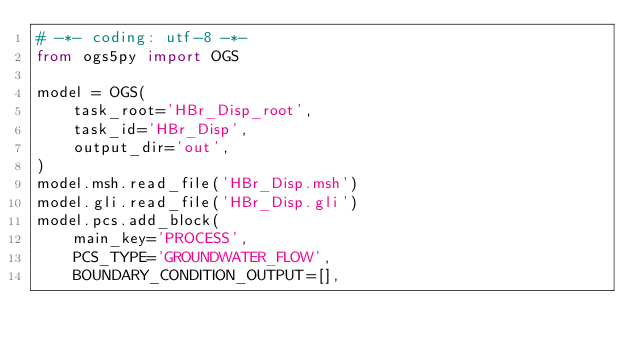<code> <loc_0><loc_0><loc_500><loc_500><_Python_># -*- coding: utf-8 -*-
from ogs5py import OGS

model = OGS(
    task_root='HBr_Disp_root',
    task_id='HBr_Disp',
    output_dir='out',
)
model.msh.read_file('HBr_Disp.msh')
model.gli.read_file('HBr_Disp.gli')
model.pcs.add_block(
    main_key='PROCESS',
    PCS_TYPE='GROUNDWATER_FLOW',
    BOUNDARY_CONDITION_OUTPUT=[],</code> 